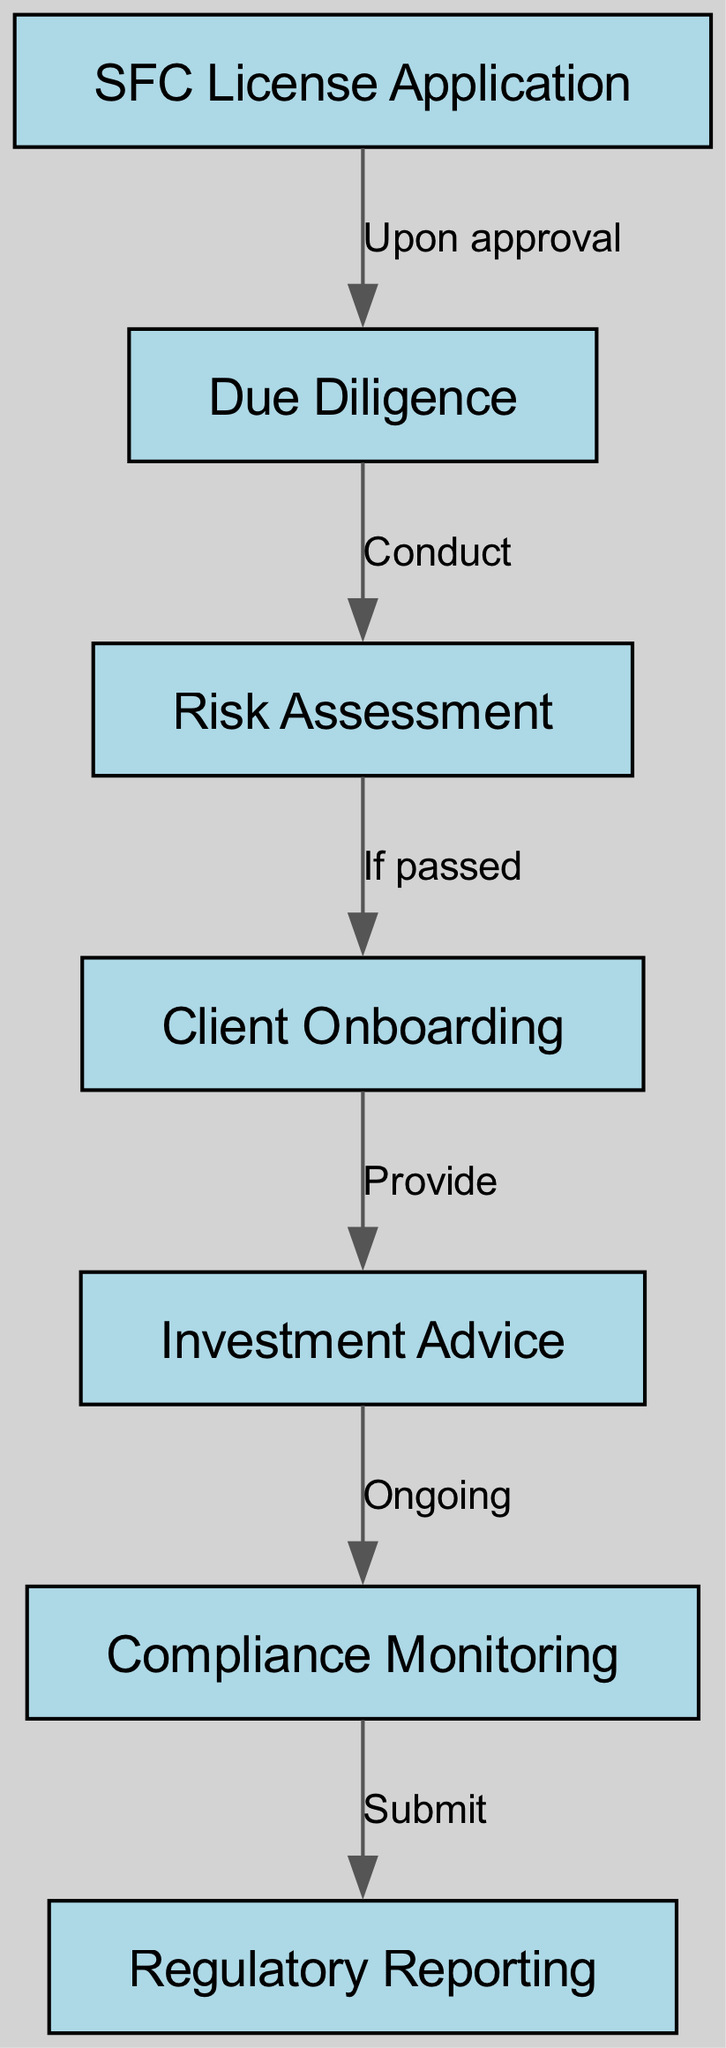What is the first step in the workflow? The first step indicated in the diagram is "SFC License Application," which is the initial process for investment advisors.
Answer: SFC License Application How many nodes are in the diagram? By counting all the unique elements shown as nodes in the diagram, we find there are seven nodes listed in total.
Answer: 7 What is the relationship between "Compliance Monitoring" and "Regulatory Reporting"? The diagram shows an edge connecting "Compliance Monitoring" to "Regulatory Reporting," labeled as "Submit," indicating that compliance information must be submitted as a report.
Answer: Submit What step follows "Risk Assessment"? According to the diagram, once "Risk Assessment" is completed and passed, the next step is "Client Onboarding," which indicates the workflow continues based on the assessment result.
Answer: Client Onboarding What action occurs after the "SFC License Application" is approved? The diagram specifies that "Due Diligence" is conducted immediately after the approval of the SFC License Application, showing a direct flow from one process to the next based on the approval.
Answer: Conduct What triggers the "Investment Advice" stage? The "Investment Advice" stage is triggered by the "Client Onboarding," which must occur first to ensure that the advisor has the necessary client information before providing advice.
Answer: Provide How does "Compliance Monitoring" link to other stages in the diagram? "Compliance Monitoring" acts as a pivotal step that connects to "Investment Advice" (ongoing) and ends with "Regulatory Reporting" (submit), indicating the importance of monitoring for compliance throughout the advisory process.
Answer: Ongoing, Submit Which step is dependent on passing "Risk Assessment"? The process labeled "Client Onboarding" specifically depends on passing the "Risk Assessment," as indicated by the edge that connects the two nodes in the diagram.
Answer: If passed What is the final stage in the compliance workflow? The diagram shows that the final stage after all the previous processes is "Regulatory Reporting," which is crucial for ensuring compliance with regulations.
Answer: Regulatory Reporting 